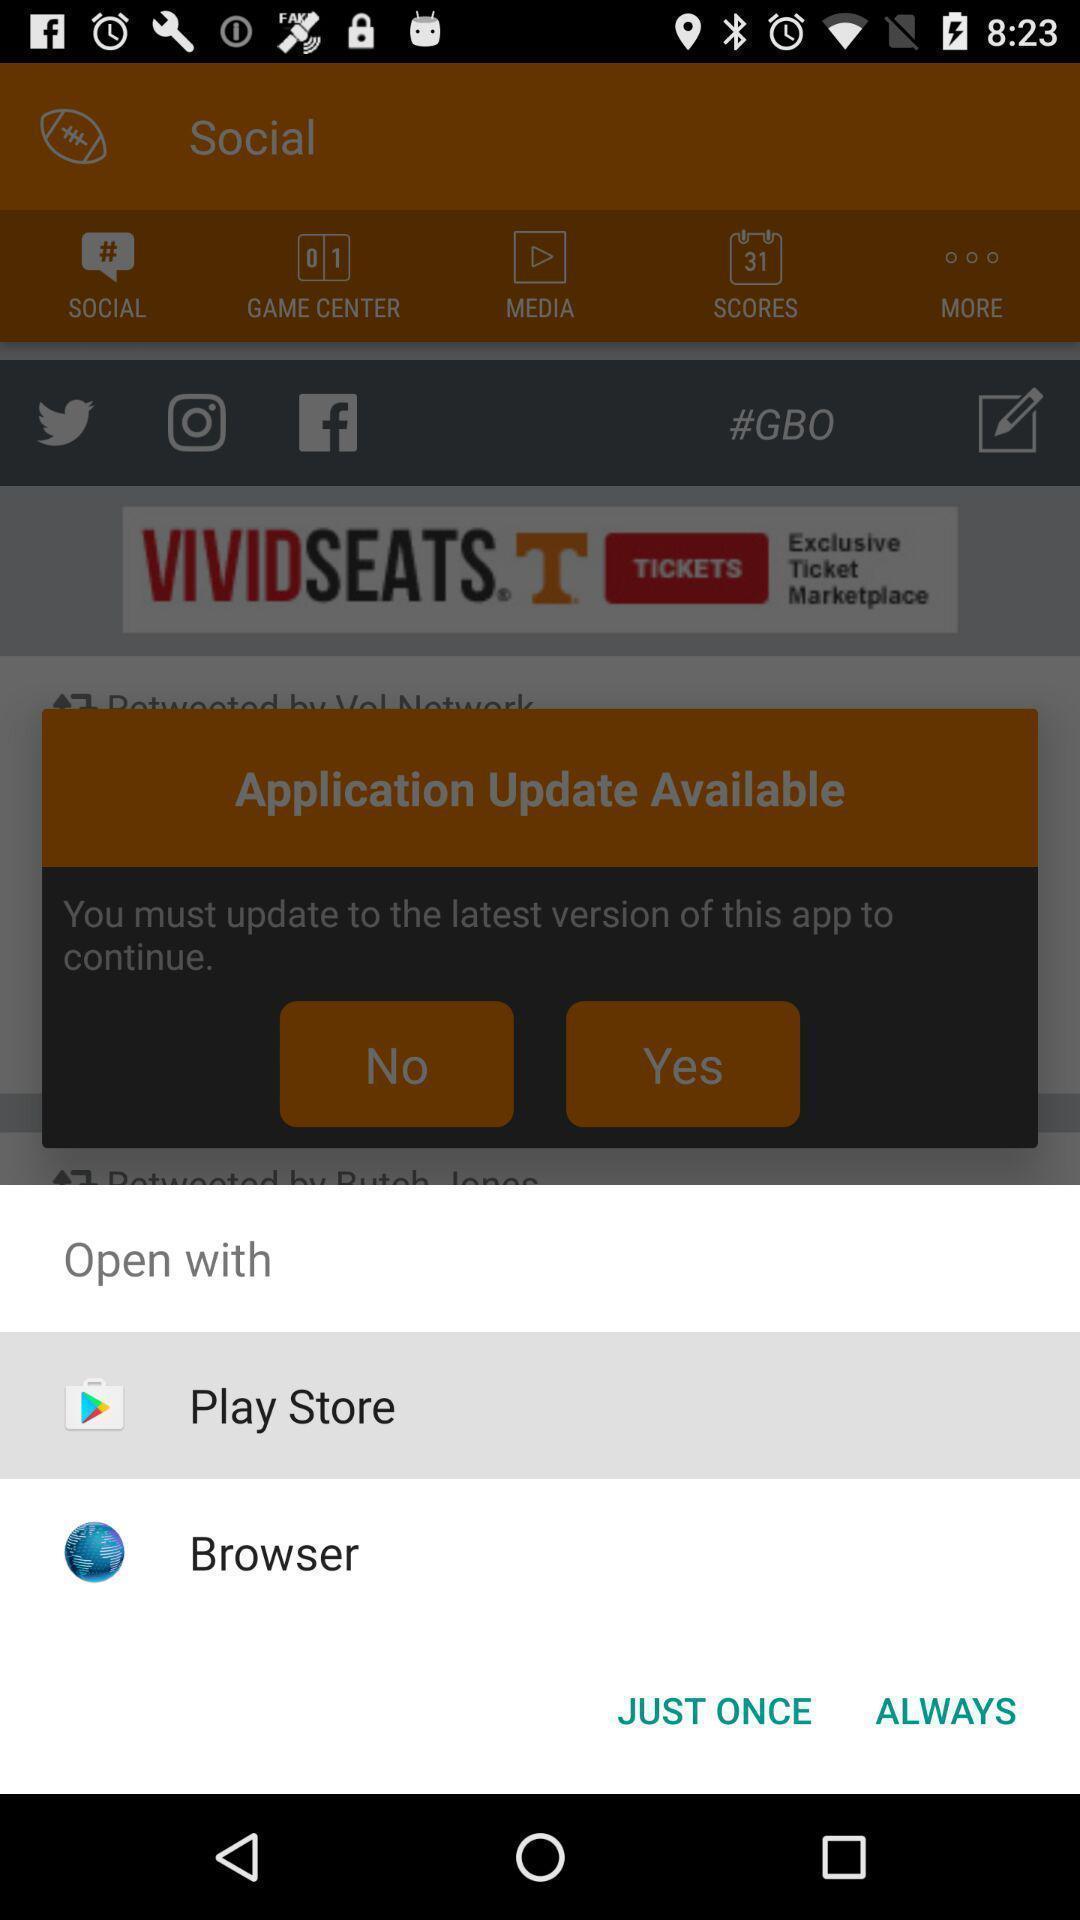Tell me what you see in this picture. Pop-up displaying the apps to open. 